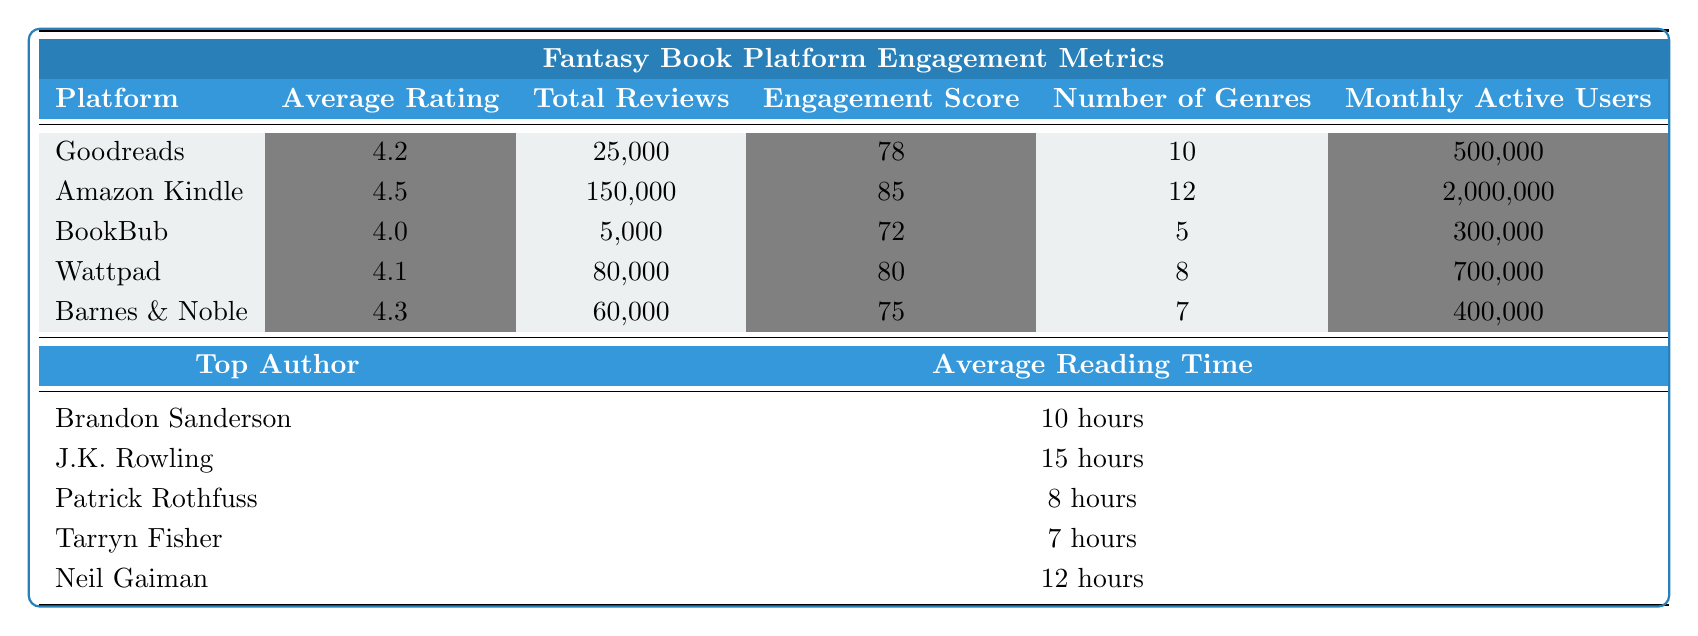What is the average rating of Amazon Kindle? The table shows that the average rating for Amazon Kindle is 4.5.
Answer: 4.5 Which platform has the highest total reviews? According to the table, Amazon Kindle has the highest total reviews at 150,000.
Answer: Amazon Kindle What is the engagement score of BookBub? The engagement score listed for BookBub in the table is 72.
Answer: 72 Which platform has the least number of genres? BookBub has the least number of genres with a count of 5.
Answer: BookBub Is it true that Wapttad has more monthly active users than Barnes & Noble? Yes, Wattpad has 700,000 monthly active users, which is more than Barnes & Noble's 400,000.
Answer: Yes Calculate the total monthly active users across all platforms. To find the total, add all monthly active users: 500,000 + 2,000,000 + 300,000 + 700,000 + 400,000 = 3,900,000.
Answer: 3,900,000 What is the average reading time across all platforms? To find the average reading time, convert each reading time to hours, sum them (10 + 15 + 8 + 7 + 12 = 52 hours) then divide by 5, giving an average of 10.4 hours.
Answer: 10.4 hours Which platform has the highest engagement score and what is it? The table indicates that Amazon Kindle has the highest engagement score of 85.
Answer: Amazon Kindle, 85 How many total reviews do Goodreads and Wattpad combined have? Add the total reviews for both platforms: 25,000 (Goodreads) + 80,000 (Wattpad) = 105,000 total reviews.
Answer: 105,000 Who is the top author on the platform with the lowest average rating? The lowest average rating is for BookBub (4.0), and the top author for that platform is Patrick Rothfuss.
Answer: Patrick Rothfuss 